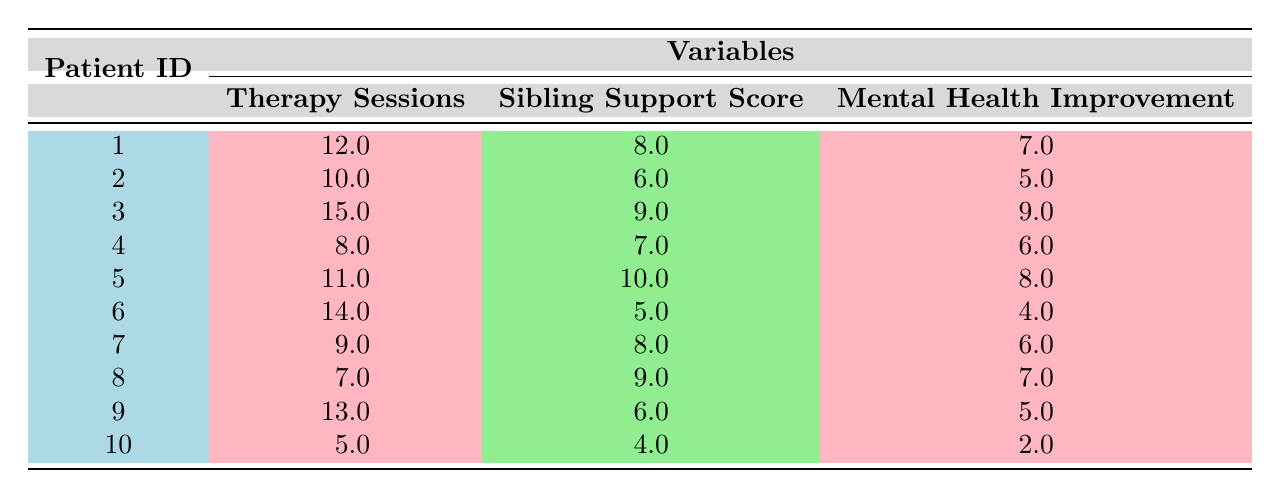What is the highest sibling support score recorded in the table? The highest sibling support score is identified by scanning the "Sibling Support Score" column for the maximum value. From the data, the maximum value is 10, associated with Patient ID 5.
Answer: 10 What is the mental health improvement score for Patient ID 3? By locating Patient ID 3 in the table, we can directly find the corresponding mental health improvement score, which is 9.
Answer: 9 How many therapy sessions did Patient ID 5 attend? To find this, we locate Patient ID 5 in the "Patient ID" column and read across to the "Therapy Sessions" column, which shows that Patient ID 5 attended 11 sessions.
Answer: 11 What is the average mental health improvement score across all patients? To calculate the average, we sum the mental health improvement scores: (7 + 5 + 9 + 6 + 8 + 4 + 6 + 7 + 5 + 2) = 59. There are 10 patients total. Thus, the average is 59/10 = 5.9.
Answer: 5.9 Does Patient ID 10 have a higher sibling support score than Patient ID 7? Upon checking, Patient ID 10 has a sibling support score of 4, while Patient ID 7 has a score of 8. Since 4 is less than 8, the answer is no.
Answer: No What is the difference in mental health improvement between the patient with the highest support score and the patient with the lowest support score? The patient with the highest sibling support score (Patient ID 5) has a mental health improvement score of 8, and the lowest (Patient ID 10) has a score of 2. The difference is calculated as 8 - 2 = 6.
Answer: 6 How many patients have more than 10 therapy sessions? We can identify the patients with more than 10 therapy sessions by scanning the "Therapy Sessions" column. Patients 3, 5, and 6 have more than 10 sessions. Counting these yields three patients.
Answer: 3 What is the median sibling support score among all patients? First, we arrange the sibling support scores in ascending order: 4, 5, 6, 6, 7, 8, 8, 9, 9, 10. With 10 scores total, the median will be the average of the 5th and 6th values, which are 7 and 8. The median is (7+8)/2 = 7.5.
Answer: 7.5 Is there any patient who has both a sibling support score and mental health improvement score of 10? Checking the table, we see that no patient has a mental health improvement score of 10, so the answer is definitely no.
Answer: No 